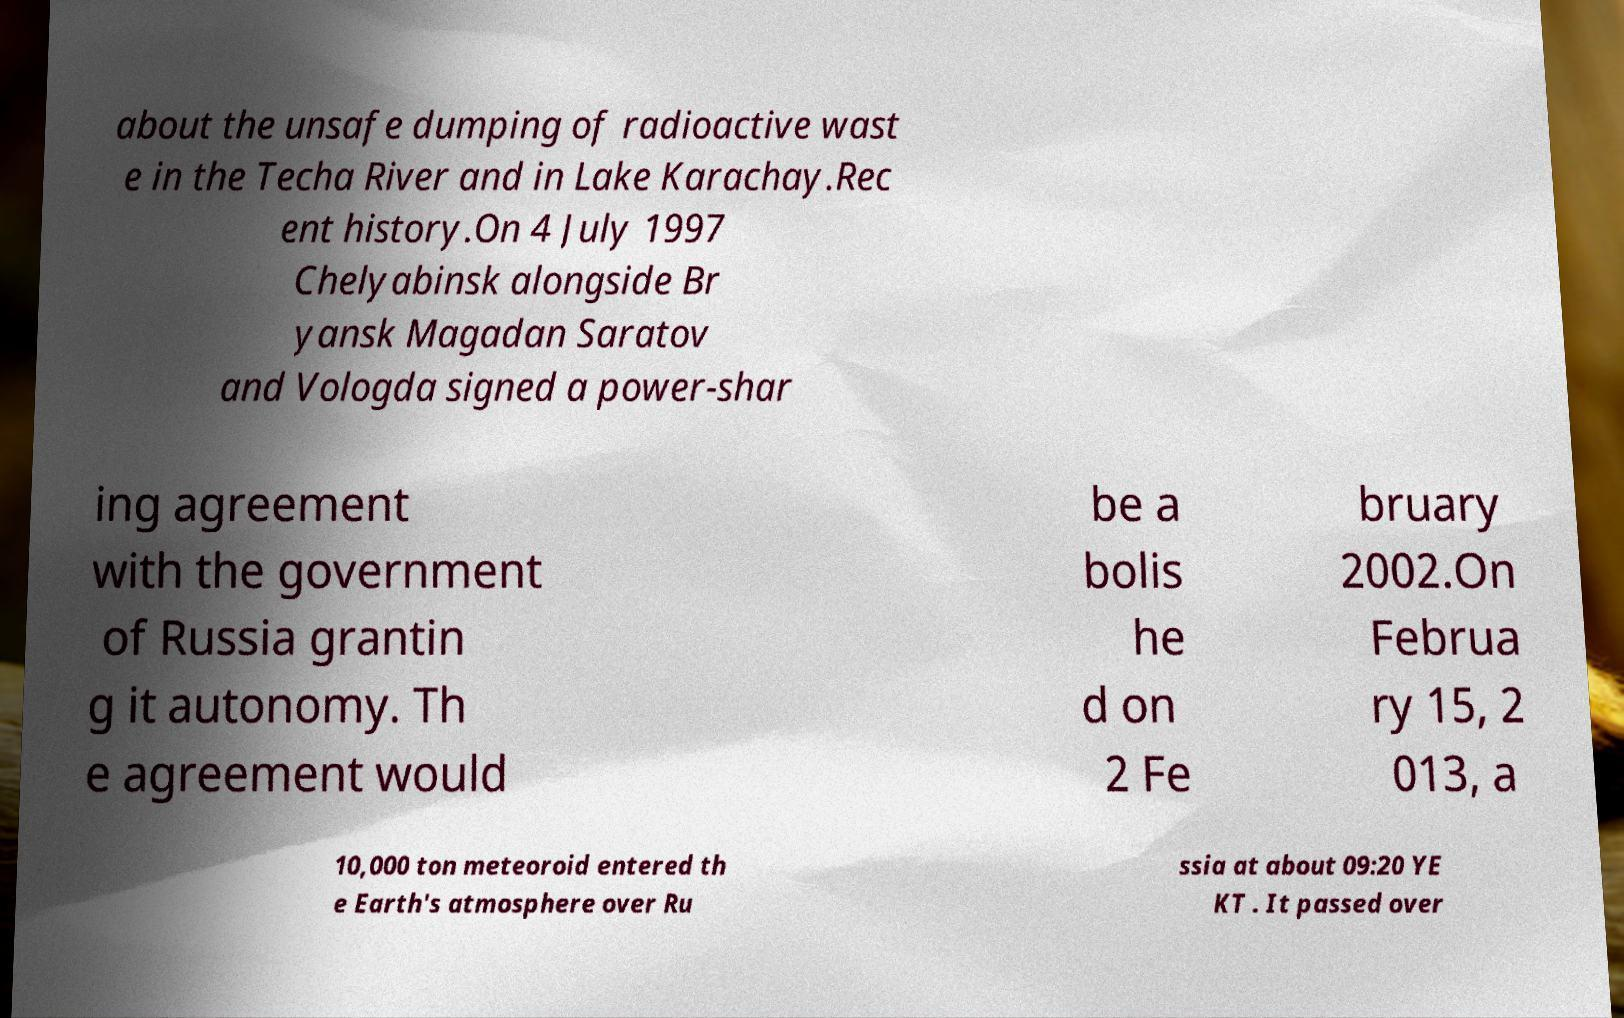Can you accurately transcribe the text from the provided image for me? about the unsafe dumping of radioactive wast e in the Techa River and in Lake Karachay.Rec ent history.On 4 July 1997 Chelyabinsk alongside Br yansk Magadan Saratov and Vologda signed a power-shar ing agreement with the government of Russia grantin g it autonomy. Th e agreement would be a bolis he d on 2 Fe bruary 2002.On Februa ry 15, 2 013, a 10,000 ton meteoroid entered th e Earth's atmosphere over Ru ssia at about 09:20 YE KT . It passed over 